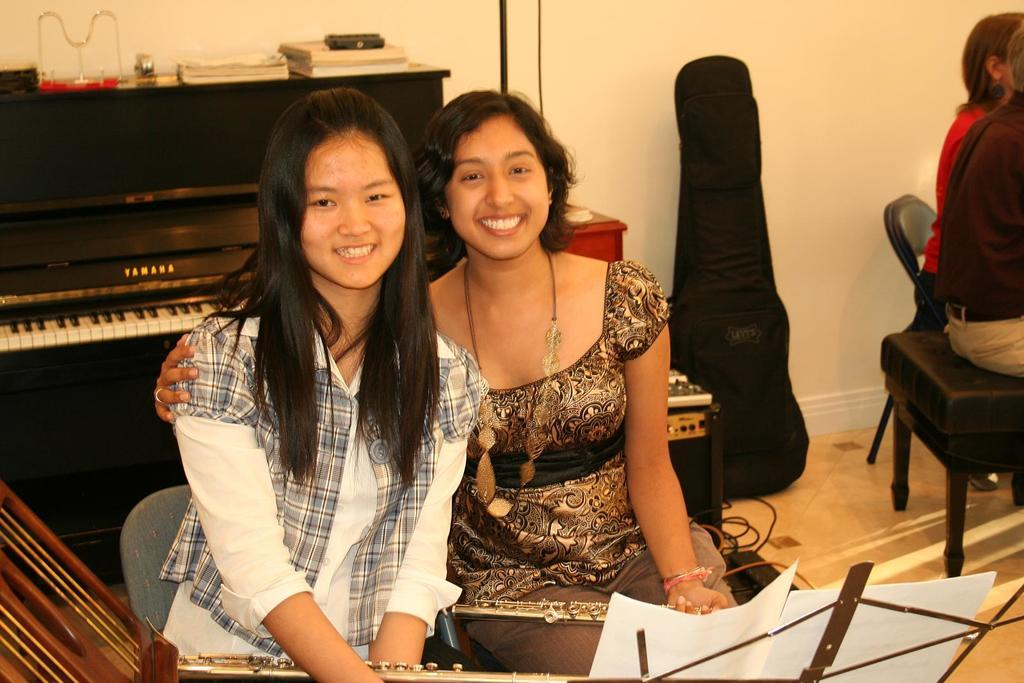How many women are in the image? There are two women in the image. What are the women doing in the image? The women are seated on chairs. What object is visible in the image that is typically used for making music? There is a piano visible in the image. What is the purpose of the paper stand in the image? The paper stand is likely used for holding sheet music or other materials related to the piano. How many people are seated on the side in the image? There are two people seated on the side in the image. What invention is being discussed during the meeting in the image? There is no meeting depicted in the image, and therefore no invention is being discussed. 